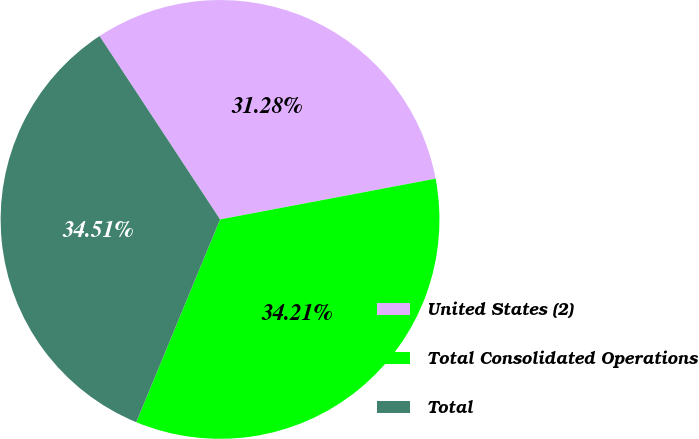Convert chart to OTSL. <chart><loc_0><loc_0><loc_500><loc_500><pie_chart><fcel>United States (2)<fcel>Total Consolidated Operations<fcel>Total<nl><fcel>31.28%<fcel>34.21%<fcel>34.51%<nl></chart> 